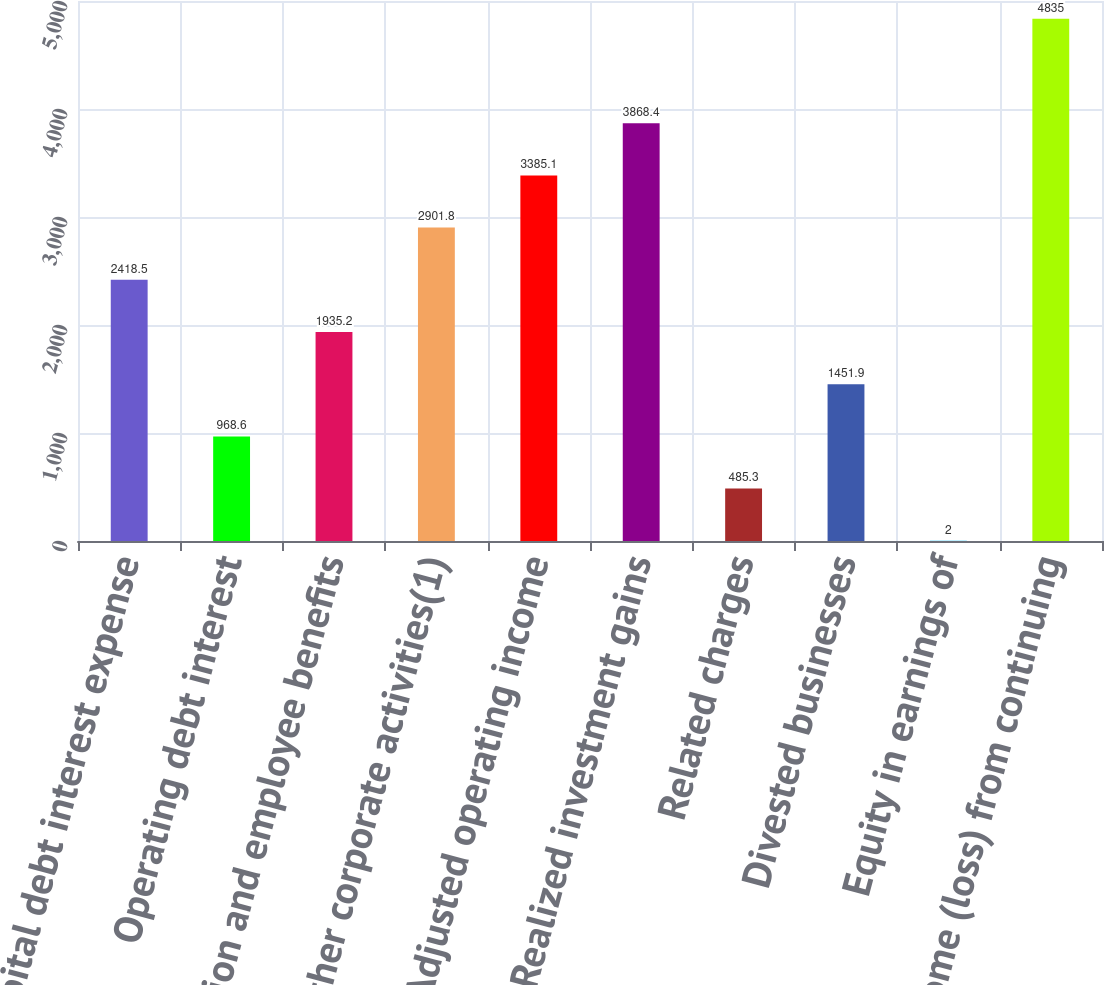Convert chart. <chart><loc_0><loc_0><loc_500><loc_500><bar_chart><fcel>Capital debt interest expense<fcel>Operating debt interest<fcel>Pension and employee benefits<fcel>Other corporate activities(1)<fcel>Adjusted operating income<fcel>Realized investment gains<fcel>Related charges<fcel>Divested businesses<fcel>Equity in earnings of<fcel>Income (loss) from continuing<nl><fcel>2418.5<fcel>968.6<fcel>1935.2<fcel>2901.8<fcel>3385.1<fcel>3868.4<fcel>485.3<fcel>1451.9<fcel>2<fcel>4835<nl></chart> 